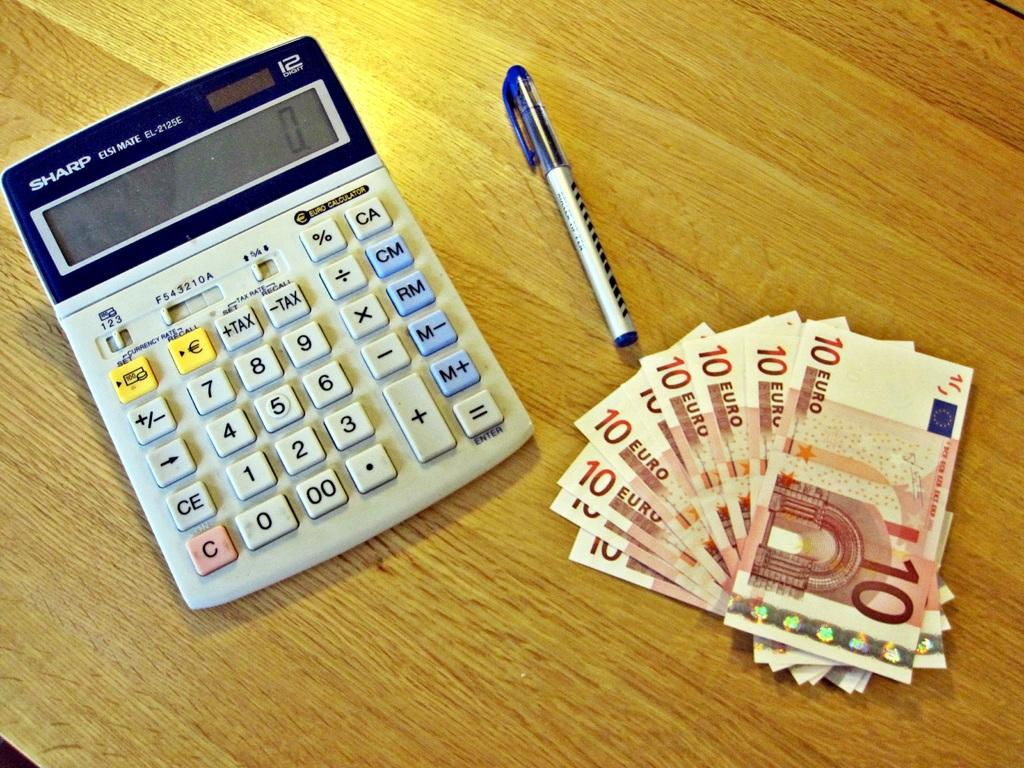<image>
Present a compact description of the photo's key features. Some ten Euro notes next to a calculator and a pen 